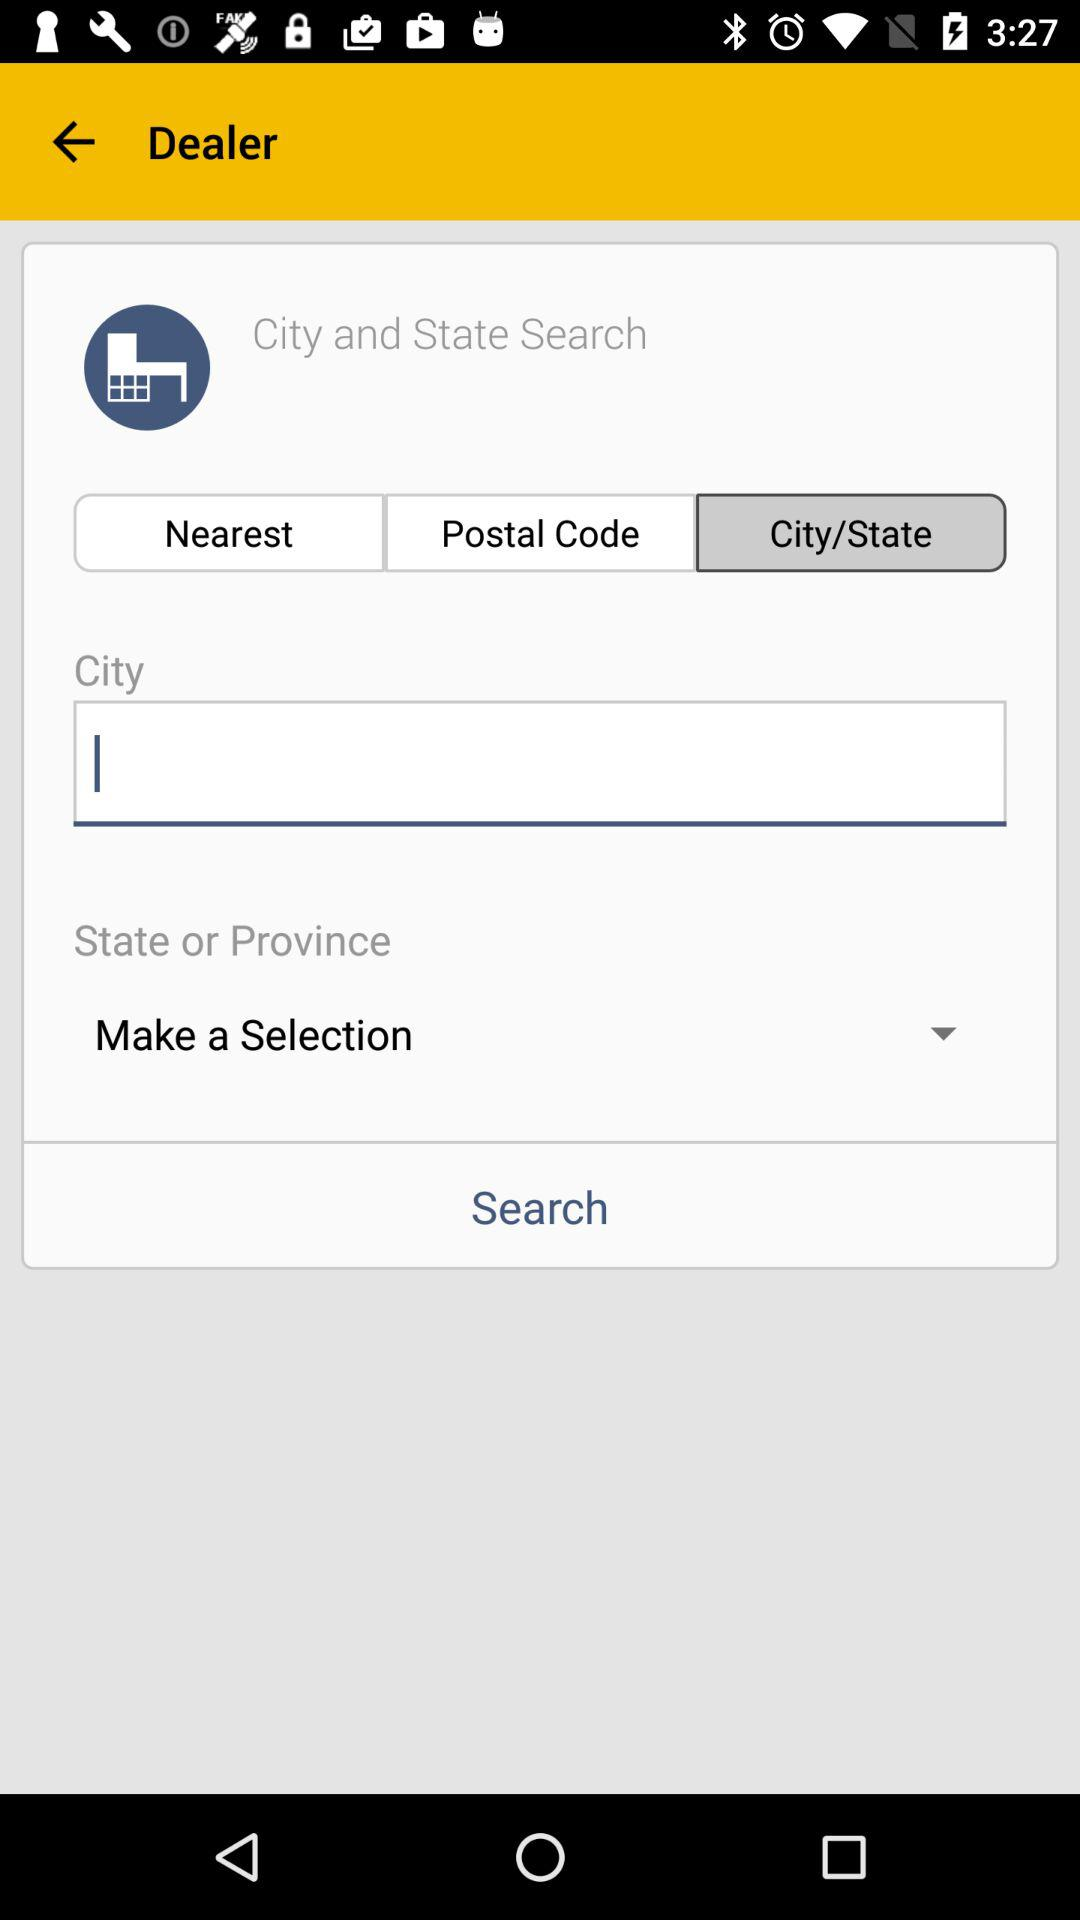Which option is selected? The selected options are "City/State" and "Make a Selection". 